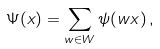Convert formula to latex. <formula><loc_0><loc_0><loc_500><loc_500>\Psi ( x ) = \sum _ { w \in W } \psi ( w x ) \, ,</formula> 